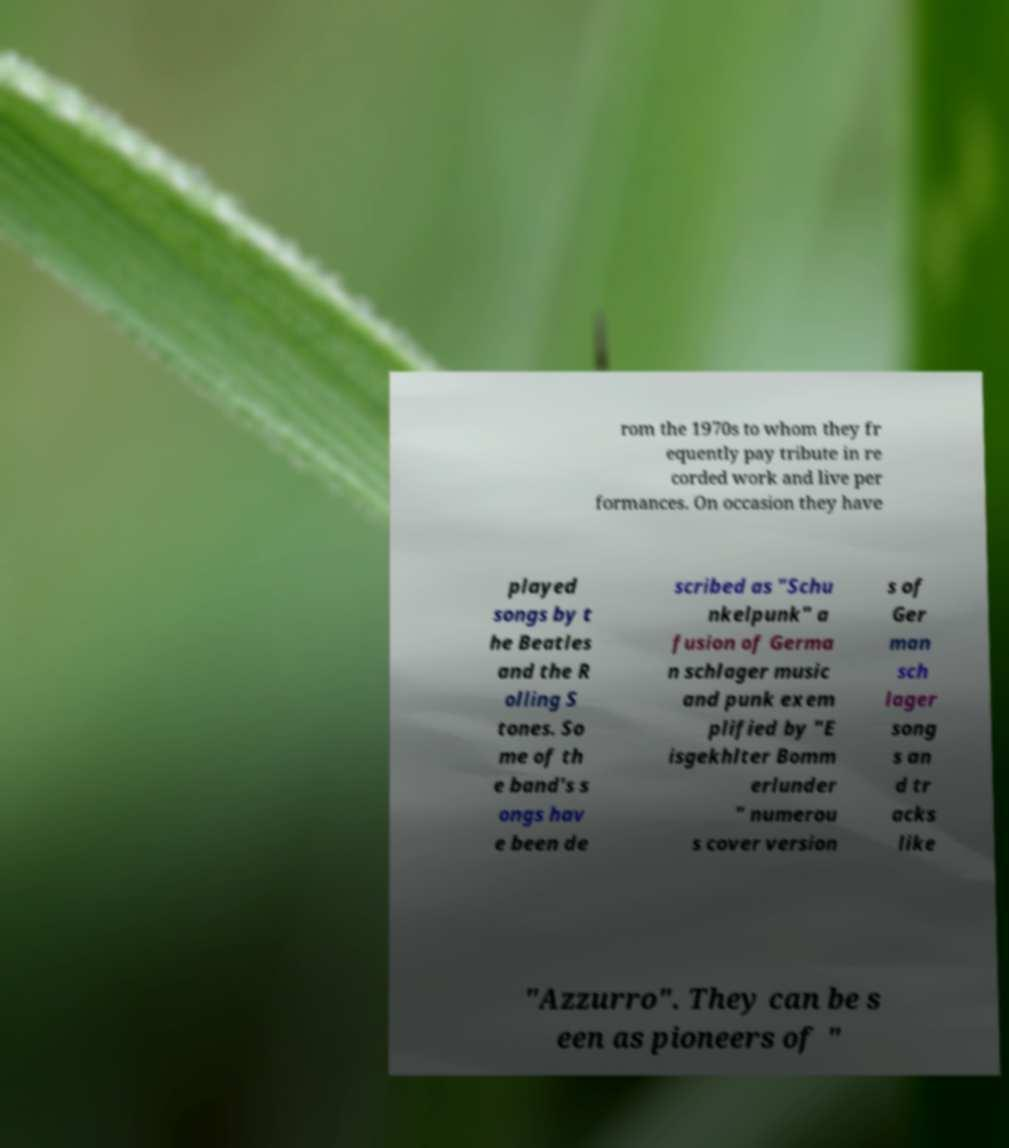Could you extract and type out the text from this image? rom the 1970s to whom they fr equently pay tribute in re corded work and live per formances. On occasion they have played songs by t he Beatles and the R olling S tones. So me of th e band's s ongs hav e been de scribed as "Schu nkelpunk" a fusion of Germa n schlager music and punk exem plified by "E isgekhlter Bomm erlunder " numerou s cover version s of Ger man sch lager song s an d tr acks like "Azzurro". They can be s een as pioneers of " 